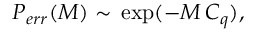<formula> <loc_0><loc_0><loc_500><loc_500>\begin{array} { r } { P _ { e r r } ( M ) \sim \, \exp ( - M \, C _ { q } ) , } \end{array}</formula> 